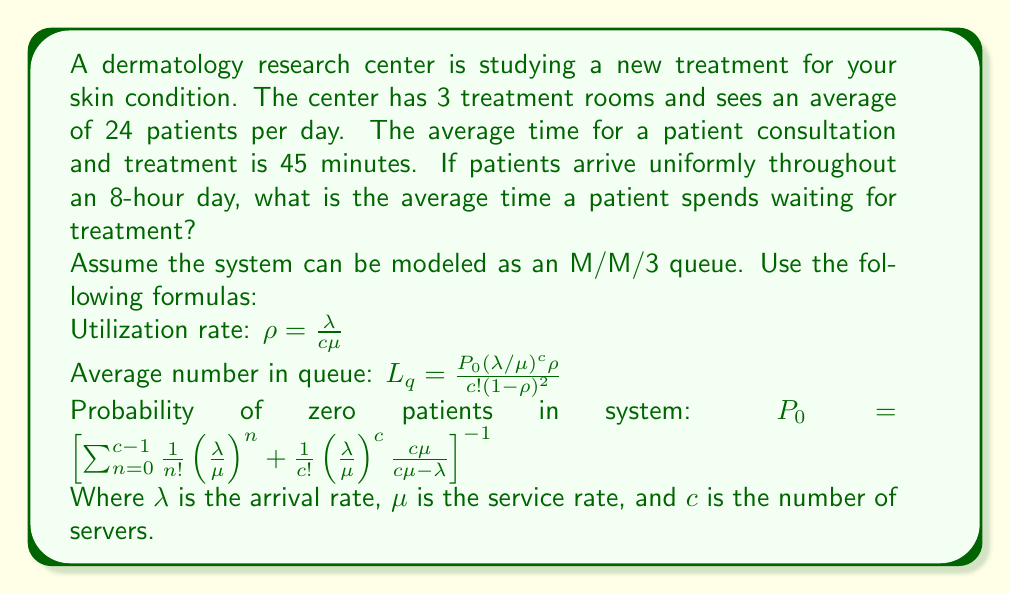Help me with this question. Let's solve this problem step by step:

1) First, calculate $\lambda$ and $\mu$:
   $\lambda = 24 \text{ patients} / 8 \text{ hours} = 3 \text{ patients/hour}$
   $\mu = 60 \text{ minutes/hour} / 45 \text{ minutes/patient} = 1.333 \text{ patients/hour}$

2) Calculate the utilization rate $\rho$:
   $\rho = \frac{\lambda}{c\mu} = \frac{3}{3 * 1.333} = 0.75$

3) Calculate $P_0$:
   $P_0 = [\sum_{n=0}^{2}\frac{1}{n!}(\frac{3}{1.333})^n + \frac{1}{3!}(\frac{3}{1.333})^3\frac{3*1.333}{3*1.333-3}]^{-1}$
   $= [1 + 2.25 + 2.53125 + 2.8476562]^{-1} = 0.1161$

4) Calculate $L_q$:
   $L_q = \frac{0.1161(3/1.333)^3 * 0.75}{3!(1-0.75)^2} = 0.9844$

5) Use Little's Law to find the average waiting time:
   $W_q = \frac{L_q}{\lambda} = \frac{0.9844}{3} = 0.3281 \text{ hours} = 19.69 \text{ minutes}$

Therefore, the average time a patient spends waiting for treatment is approximately 19.69 minutes.
Answer: 19.69 minutes 